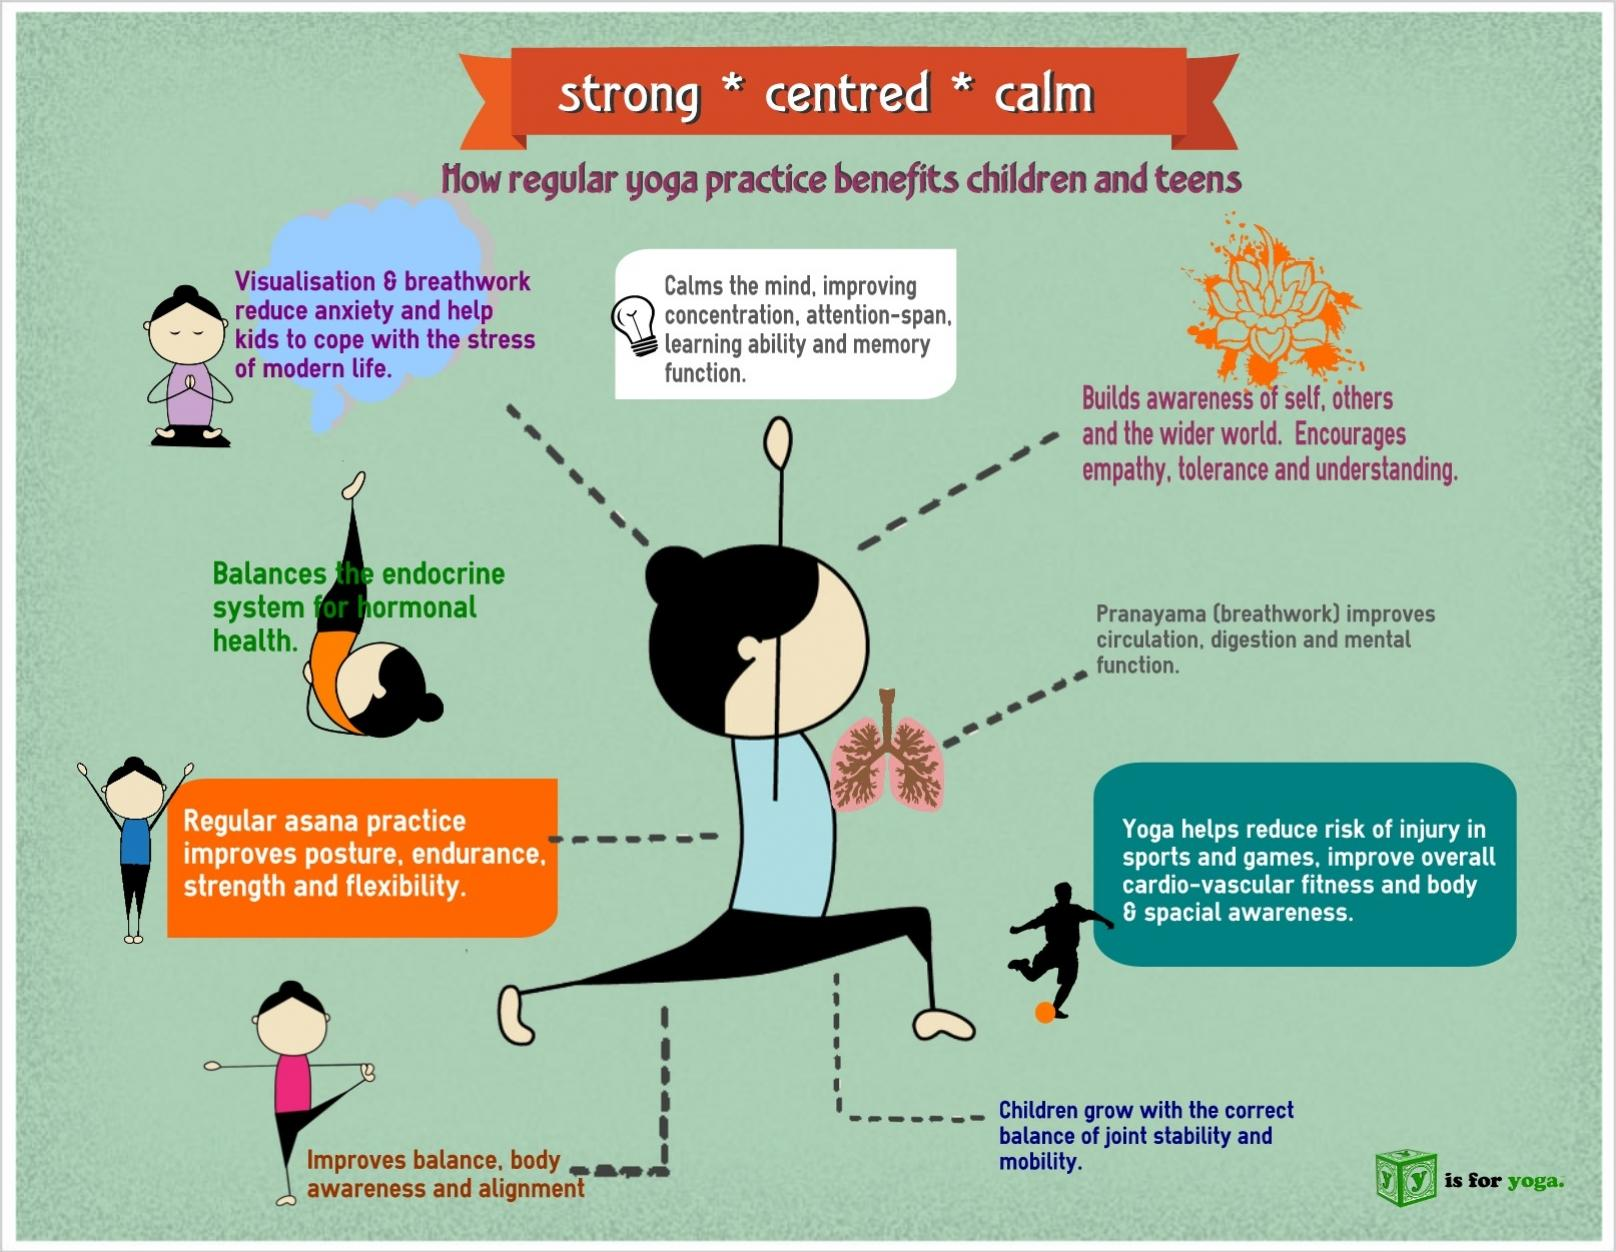Indicate a few pertinent items in this graphic. Pranayama is a breathing exercise that has been found to effectively reduce anxiety in children. Nine benefits can be received by children through the practice of yoga. 